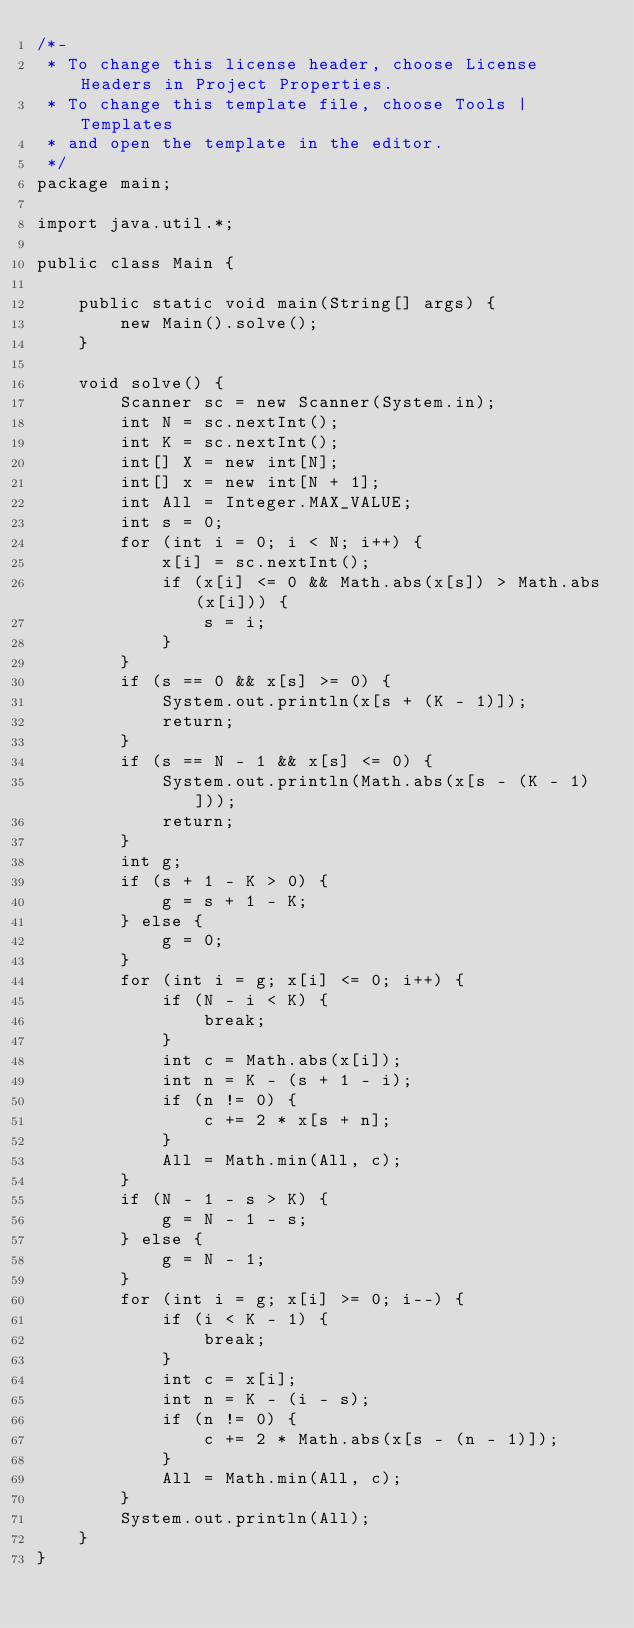Convert code to text. <code><loc_0><loc_0><loc_500><loc_500><_Java_>/*-
 * To change this license header, choose License Headers in Project Properties.
 * To change this template file, choose Tools | Templates
 * and open the template in the editor.
 */
package main;

import java.util.*;

public class Main {

    public static void main(String[] args) {
        new Main().solve();
    }

    void solve() {
        Scanner sc = new Scanner(System.in);
        int N = sc.nextInt();
        int K = sc.nextInt();
        int[] X = new int[N];
        int[] x = new int[N + 1];
        int All = Integer.MAX_VALUE;
        int s = 0;
        for (int i = 0; i < N; i++) {
            x[i] = sc.nextInt();
            if (x[i] <= 0 && Math.abs(x[s]) > Math.abs(x[i])) {
                s = i;
            }
        }
        if (s == 0 && x[s] >= 0) {
            System.out.println(x[s + (K - 1)]);
            return;
        }
        if (s == N - 1 && x[s] <= 0) {
            System.out.println(Math.abs(x[s - (K - 1)]));
            return;
        }
        int g;
        if (s + 1 - K > 0) {
            g = s + 1 - K;
        } else {
            g = 0;
        }
        for (int i = g; x[i] <= 0; i++) {
            if (N - i < K) {
                break;
            }
            int c = Math.abs(x[i]);
            int n = K - (s + 1 - i);
            if (n != 0) {
                c += 2 * x[s + n];
            }
            All = Math.min(All, c);
        }
        if (N - 1 - s > K) {
            g = N - 1 - s;
        } else {
            g = N - 1;
        }
        for (int i = g; x[i] >= 0; i--) {
            if (i < K - 1) {
                break;
            }
            int c = x[i];
            int n = K - (i - s);
            if (n != 0) {
                c += 2 * Math.abs(x[s - (n - 1)]);
            }
            All = Math.min(All, c);
        }
        System.out.println(All);
    }
}
</code> 